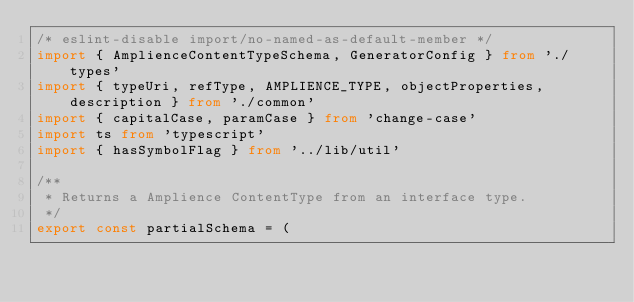Convert code to text. <code><loc_0><loc_0><loc_500><loc_500><_TypeScript_>/* eslint-disable import/no-named-as-default-member */
import { AmplienceContentTypeSchema, GeneratorConfig } from './types'
import { typeUri, refType, AMPLIENCE_TYPE, objectProperties, description } from './common'
import { capitalCase, paramCase } from 'change-case'
import ts from 'typescript'
import { hasSymbolFlag } from '../lib/util'

/**
 * Returns a Amplience ContentType from an interface type.
 */
export const partialSchema = (</code> 